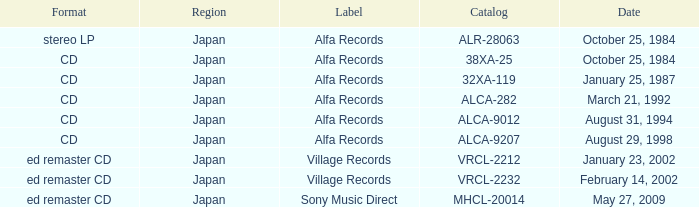Parse the table in full. {'header': ['Format', 'Region', 'Label', 'Catalog', 'Date'], 'rows': [['stereo LP', 'Japan', 'Alfa Records', 'ALR-28063', 'October 25, 1984'], ['CD', 'Japan', 'Alfa Records', '38XA-25', 'October 25, 1984'], ['CD', 'Japan', 'Alfa Records', '32XA-119', 'January 25, 1987'], ['CD', 'Japan', 'Alfa Records', 'ALCA-282', 'March 21, 1992'], ['CD', 'Japan', 'Alfa Records', 'ALCA-9012', 'August 31, 1994'], ['CD', 'Japan', 'Alfa Records', 'ALCA-9207', 'August 29, 1998'], ['ed remaster CD', 'Japan', 'Village Records', 'VRCL-2212', 'January 23, 2002'], ['ed remaster CD', 'Japan', 'Village Records', 'VRCL-2232', 'February 14, 2002'], ['ed remaster CD', 'Japan', 'Sony Music Direct', 'MHCL-20014', 'May 27, 2009']]} What is the catalog of the release from January 23, 2002? VRCL-2212. 